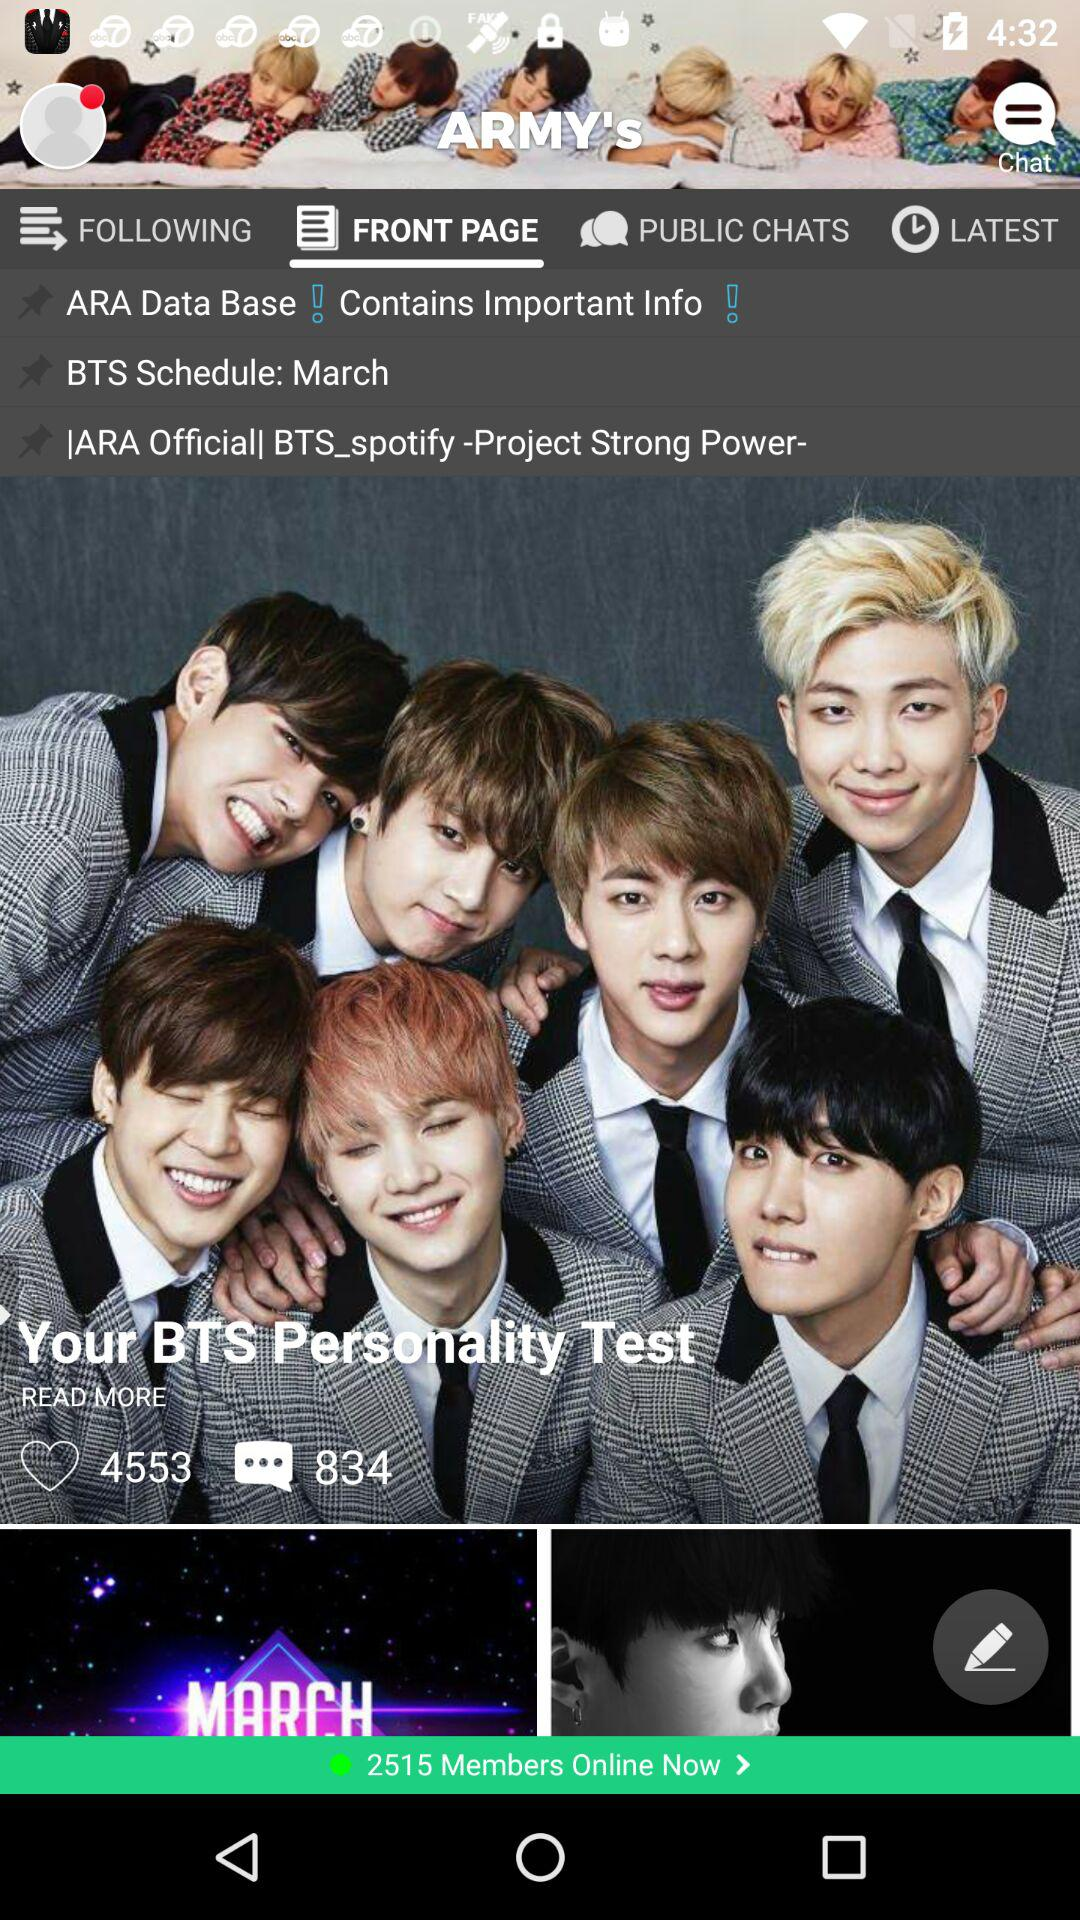How many likes are there? There are 4553 likes. 